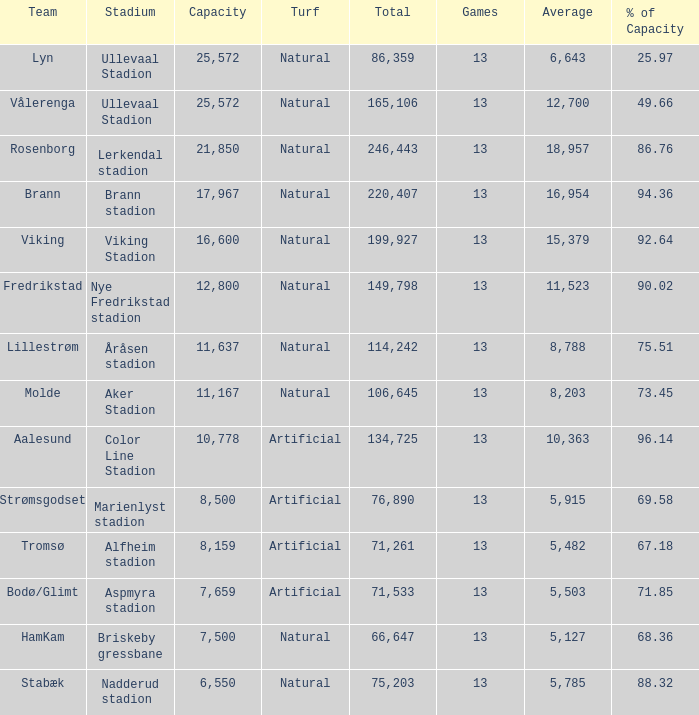I'm looking to parse the entire table for insights. Could you assist me with that? {'header': ['Team', 'Stadium', 'Capacity', 'Turf', 'Total', 'Games', 'Average', '% of Capacity'], 'rows': [['Lyn', 'Ullevaal Stadion', '25,572', 'Natural', '86,359', '13', '6,643', '25.97'], ['Vålerenga', 'Ullevaal Stadion', '25,572', 'Natural', '165,106', '13', '12,700', '49.66'], ['Rosenborg', 'Lerkendal stadion', '21,850', 'Natural', '246,443', '13', '18,957', '86.76'], ['Brann', 'Brann stadion', '17,967', 'Natural', '220,407', '13', '16,954', '94.36'], ['Viking', 'Viking Stadion', '16,600', 'Natural', '199,927', '13', '15,379', '92.64'], ['Fredrikstad', 'Nye Fredrikstad stadion', '12,800', 'Natural', '149,798', '13', '11,523', '90.02'], ['Lillestrøm', 'Åråsen stadion', '11,637', 'Natural', '114,242', '13', '8,788', '75.51'], ['Molde', 'Aker Stadion', '11,167', 'Natural', '106,645', '13', '8,203', '73.45'], ['Aalesund', 'Color Line Stadion', '10,778', 'Artificial', '134,725', '13', '10,363', '96.14'], ['Strømsgodset', 'Marienlyst stadion', '8,500', 'Artificial', '76,890', '13', '5,915', '69.58'], ['Tromsø', 'Alfheim stadion', '8,159', 'Artificial', '71,261', '13', '5,482', '67.18'], ['Bodø/Glimt', 'Aspmyra stadion', '7,659', 'Artificial', '71,533', '13', '5,503', '71.85'], ['HamKam', 'Briskeby gressbane', '7,500', 'Natural', '66,647', '13', '5,127', '68.36'], ['Stabæk', 'Nadderud stadion', '6,550', 'Natural', '75,203', '13', '5,785', '88.32']]} What was the complete turnout for aalesund when it had a capacity greater than 96.14%? None. 